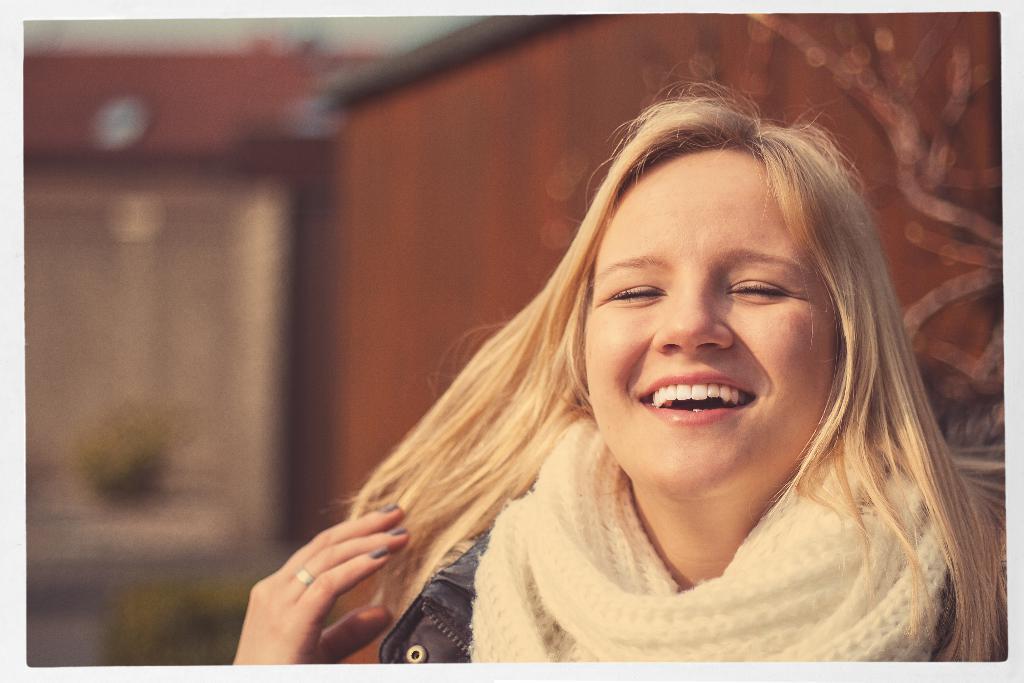How would you summarize this image in a sentence or two? In this picture there is a girl on the right side of the image, she is laughing and the background area of the image is blurred. 